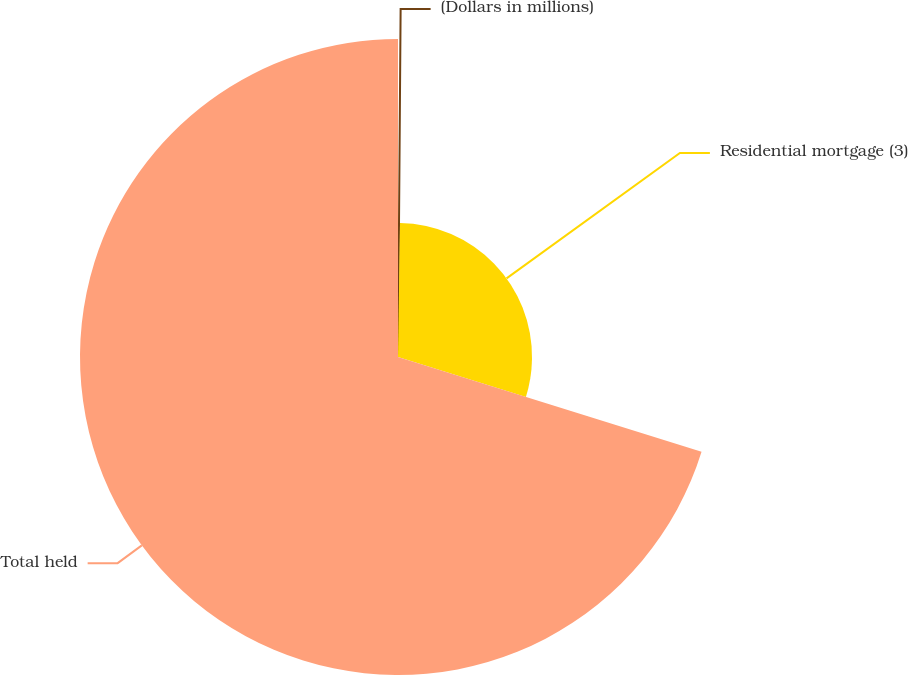Convert chart. <chart><loc_0><loc_0><loc_500><loc_500><pie_chart><fcel>(Dollars in millions)<fcel>Residential mortgage (3)<fcel>Total held<nl><fcel>0.24%<fcel>29.58%<fcel>70.19%<nl></chart> 